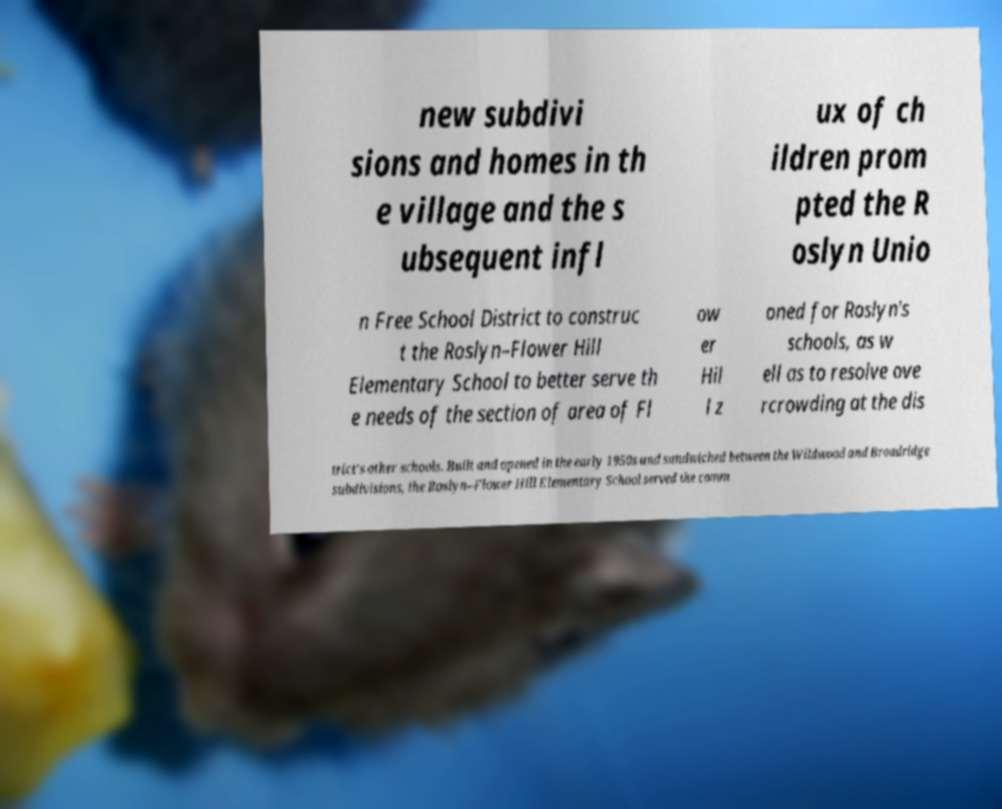I need the written content from this picture converted into text. Can you do that? new subdivi sions and homes in th e village and the s ubsequent infl ux of ch ildren prom pted the R oslyn Unio n Free School District to construc t the Roslyn–Flower Hill Elementary School to better serve th e needs of the section of area of Fl ow er Hil l z oned for Roslyn's schools, as w ell as to resolve ove rcrowding at the dis trict's other schools. Built and opened in the early 1950s and sandwiched between the Wildwood and Broadridge subdivisions, the Roslyn–Flower Hill Elementary School served the comm 